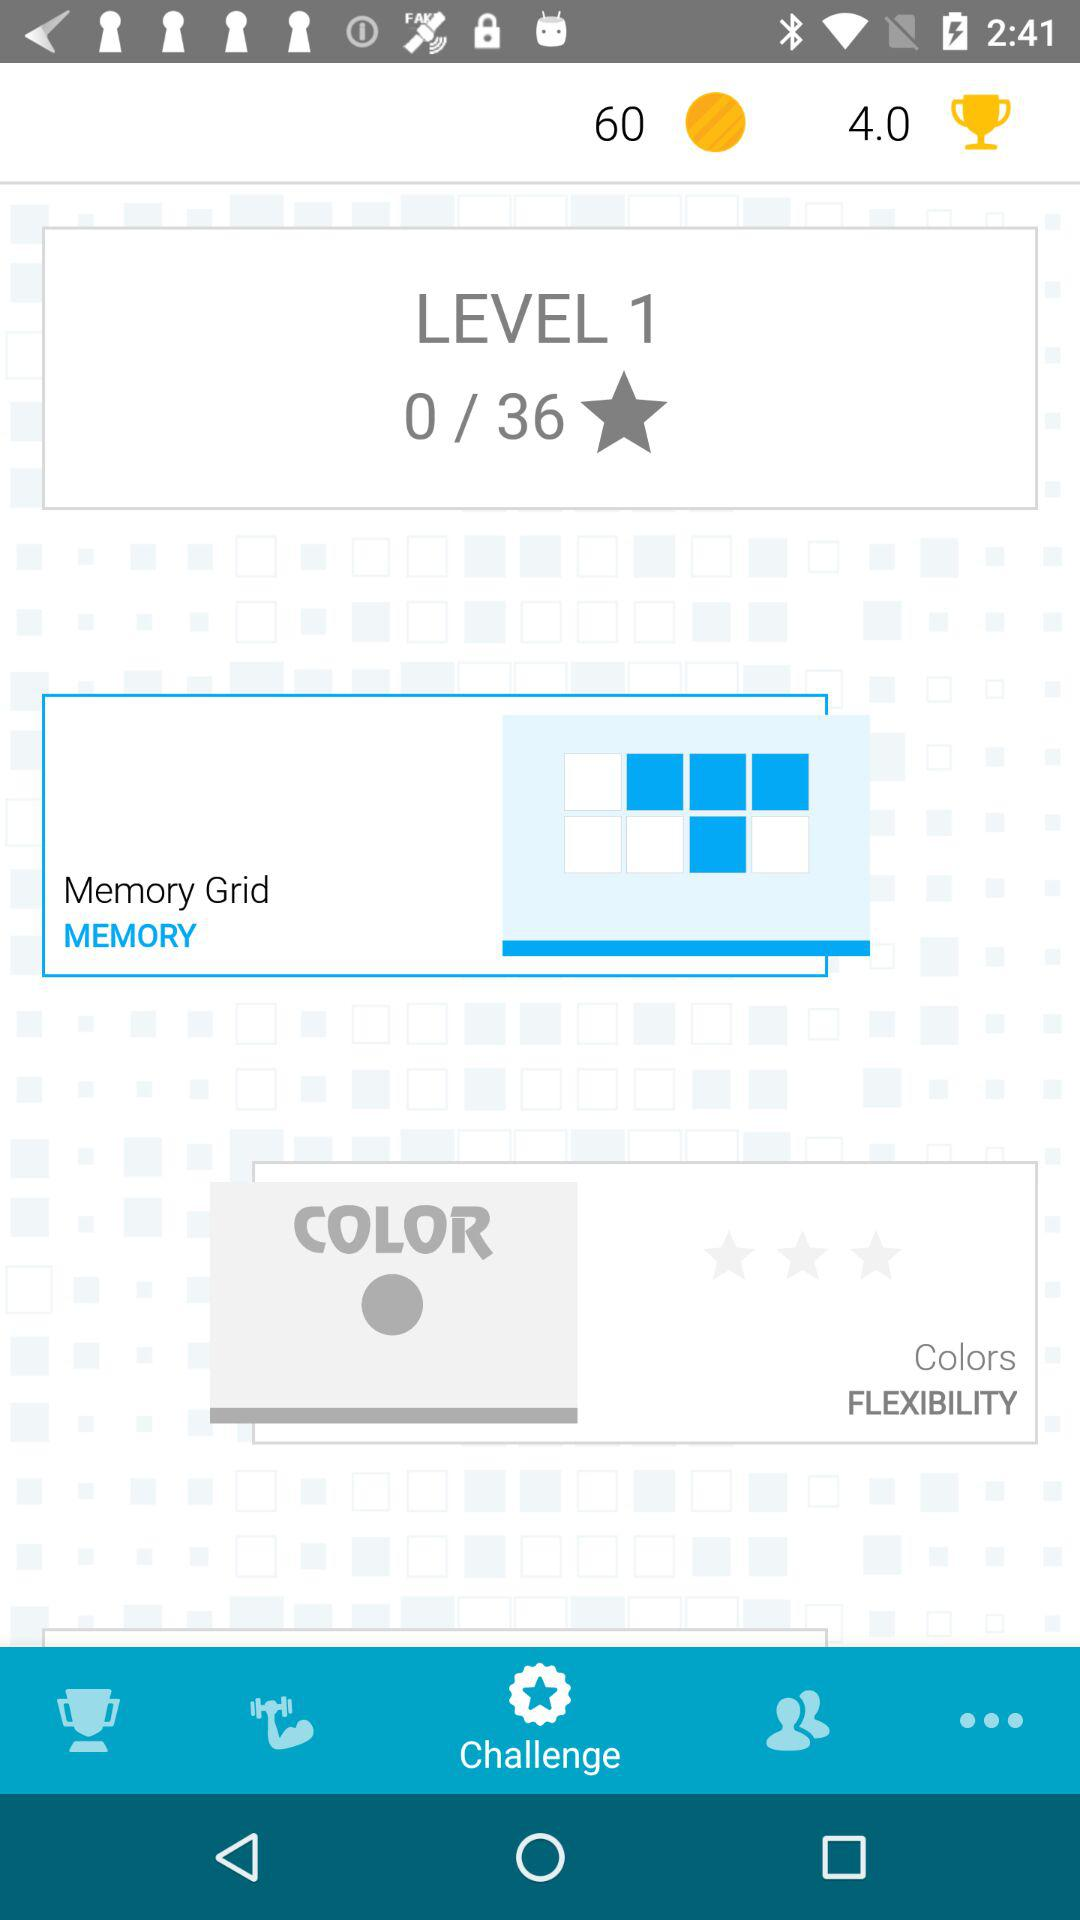How many coins can be earned at level 22?
When the provided information is insufficient, respond with <no answer>. <no answer> 